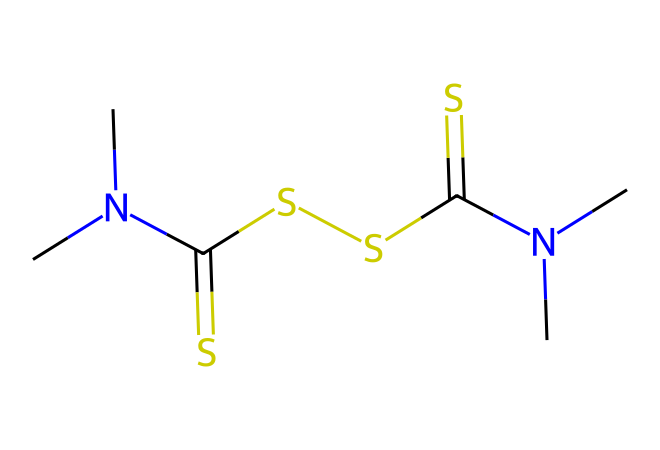What is the total number of sulfur atoms in this compound? The given SMILES representation contains two occurrences of "S" and "C(=S)" which denotes sulfur atoms. Counting these gives a total of four sulfur atoms.
Answer: four How many nitrogen atoms are present in the structure? The SMILES notation shows "N(C)C" twice, indicating there are two nitrogen atoms in total, as each "N" represents one nitrogen.
Answer: two What functional groups are present in this molecule? The molecule has thiocarbonyl groups (C=S) which signify the presence of sulfur, and amine groups (N(C)C) which point to nitrogen functionality.
Answer: thiocarbonyl, amine How many carbon atoms are indicated in the structure? By analyzing the SMILES, we see there are 4 carbon atoms based on the "C" symbols present, including those in the amine groups and those in thiocarbonyl.
Answer: four What is the chemical name for this compound? The chemical represented by the given SMILES is known as thiram. This name is derived from the function and specific arrangement of atoms within the molecule.
Answer: thiram Which characteristic of this compound is responsible for its fungicidal properties? The presence of the thiocarbonyl (C=S) groups is crucial as it is these groups that contribute to the compound's antifungal activity.
Answer: thiocarbonyl How many total atoms are present in this molecule? Counting all the atoms represented in the SMILES notation, we have 4 carbon, 4 sulfur, and 2 nitrogen, determining the total atoms as 10.
Answer: ten 